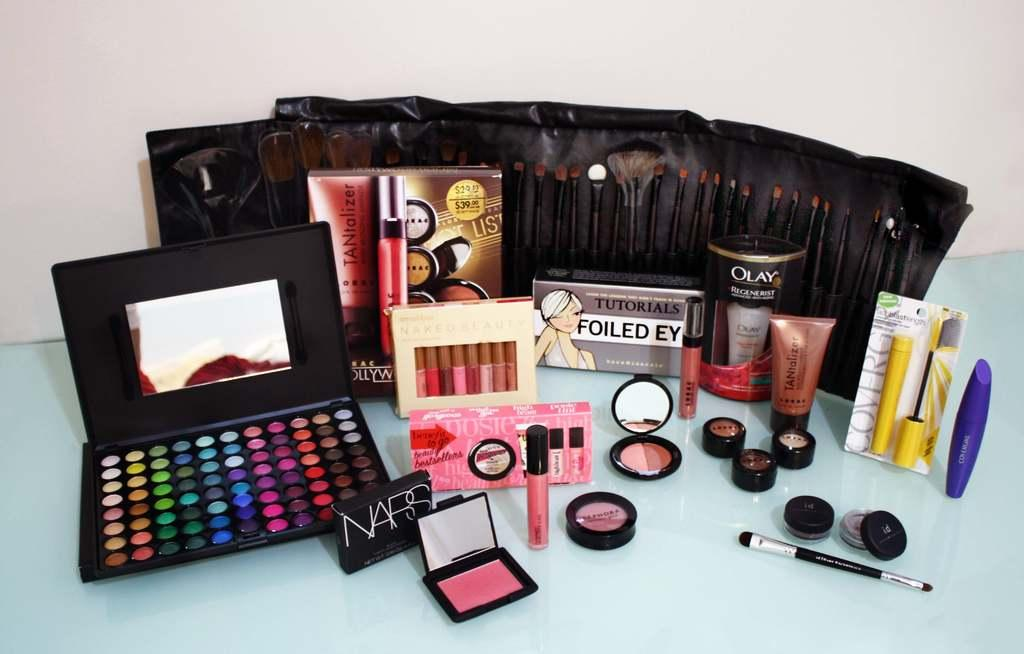<image>
Render a clear and concise summary of the photo. a group of makeup items with one called Naps 